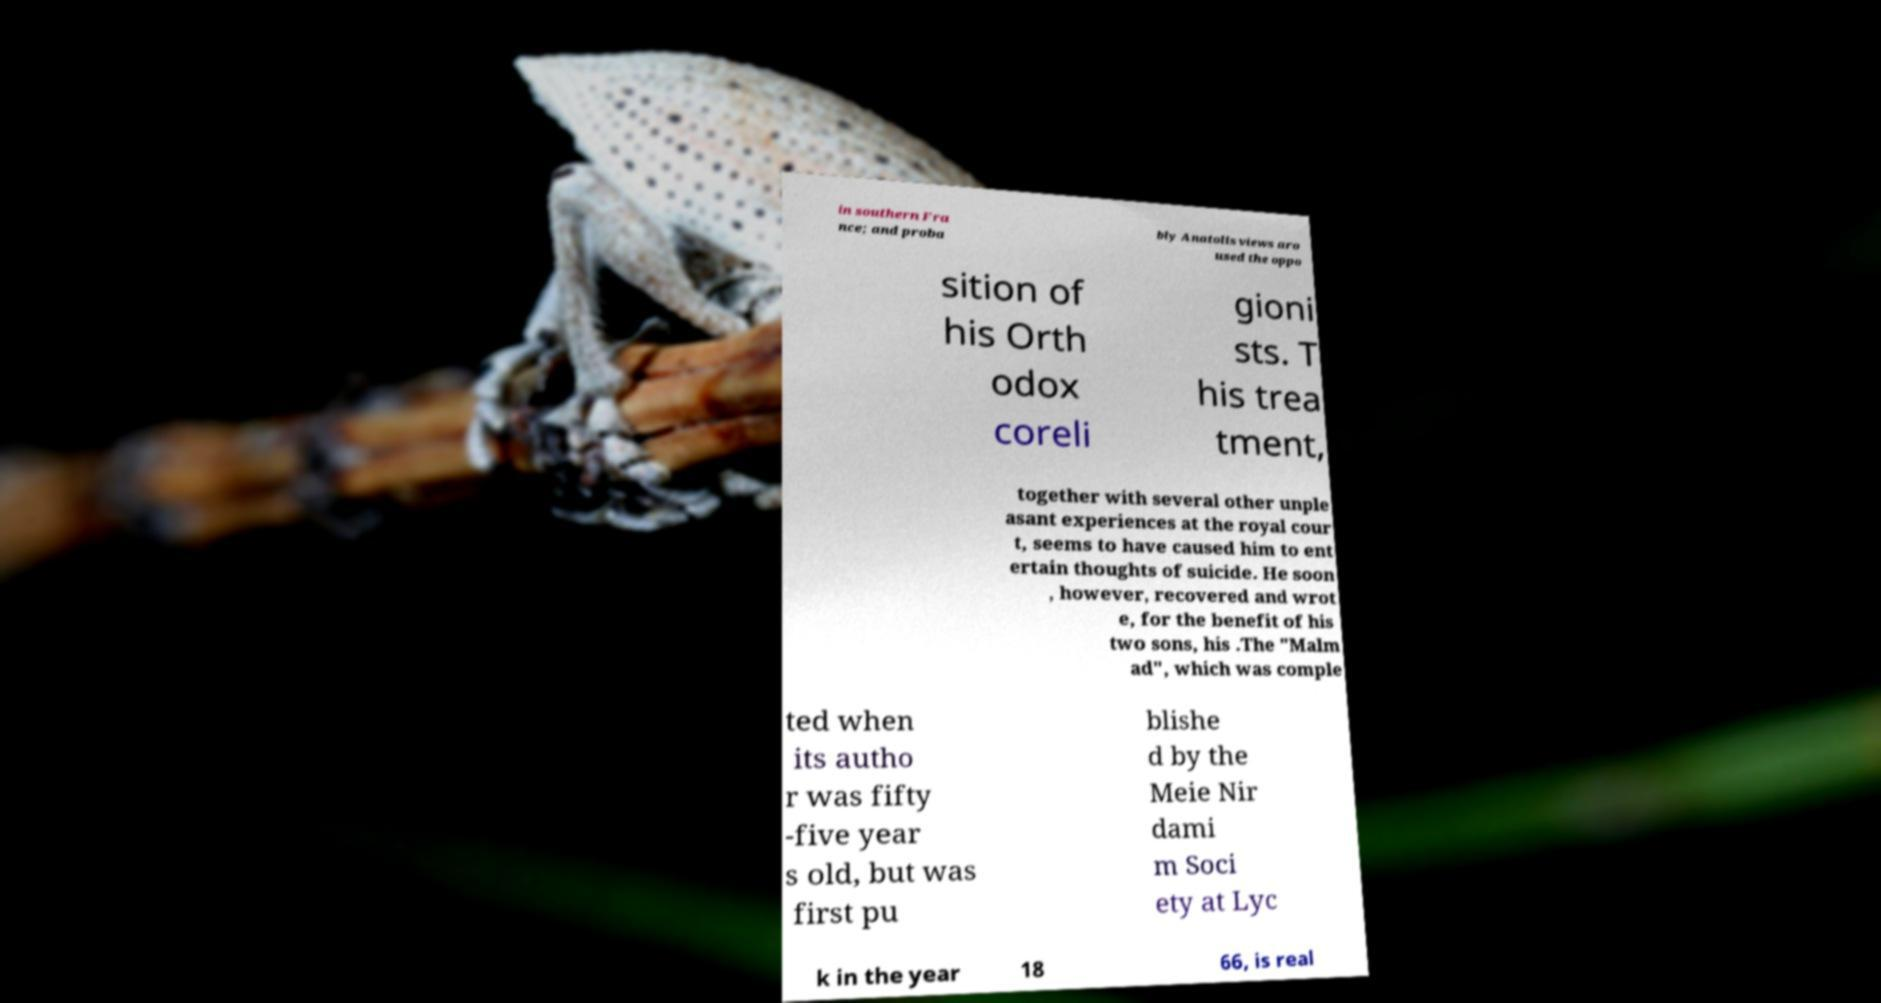There's text embedded in this image that I need extracted. Can you transcribe it verbatim? in southern Fra nce; and proba bly Anatolis views aro used the oppo sition of his Orth odox coreli gioni sts. T his trea tment, together with several other unple asant experiences at the royal cour t, seems to have caused him to ent ertain thoughts of suicide. He soon , however, recovered and wrot e, for the benefit of his two sons, his .The "Malm ad", which was comple ted when its autho r was fifty -five year s old, but was first pu blishe d by the Meie Nir dami m Soci ety at Lyc k in the year 18 66, is real 